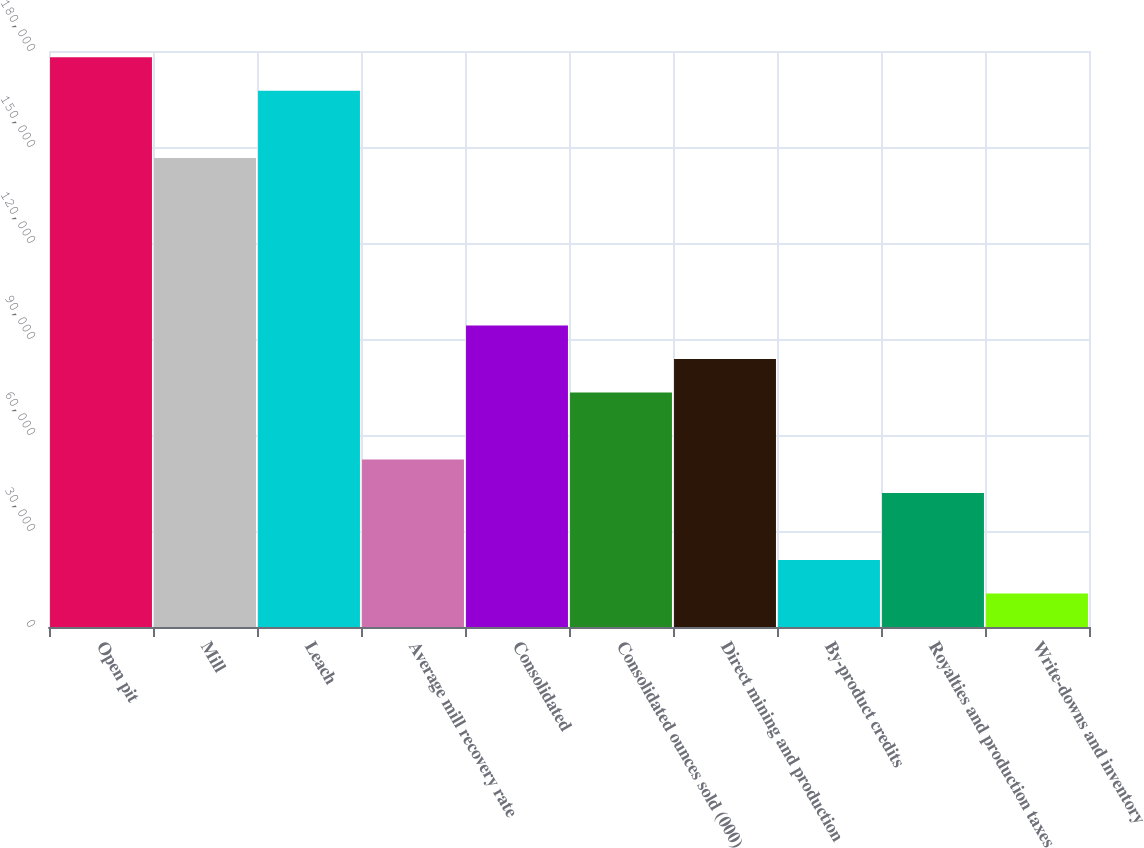<chart> <loc_0><loc_0><loc_500><loc_500><bar_chart><fcel>Open pit<fcel>Mill<fcel>Leach<fcel>Average mill recovery rate<fcel>Consolidated<fcel>Consolidated ounces sold (000)<fcel>Direct mining and production<fcel>By-product credits<fcel>Royalties and production taxes<fcel>Write-downs and inventory<nl><fcel>178012<fcel>146598<fcel>167541<fcel>52356.5<fcel>94241.7<fcel>73299.1<fcel>83770.4<fcel>20942.6<fcel>41885.2<fcel>10471.3<nl></chart> 